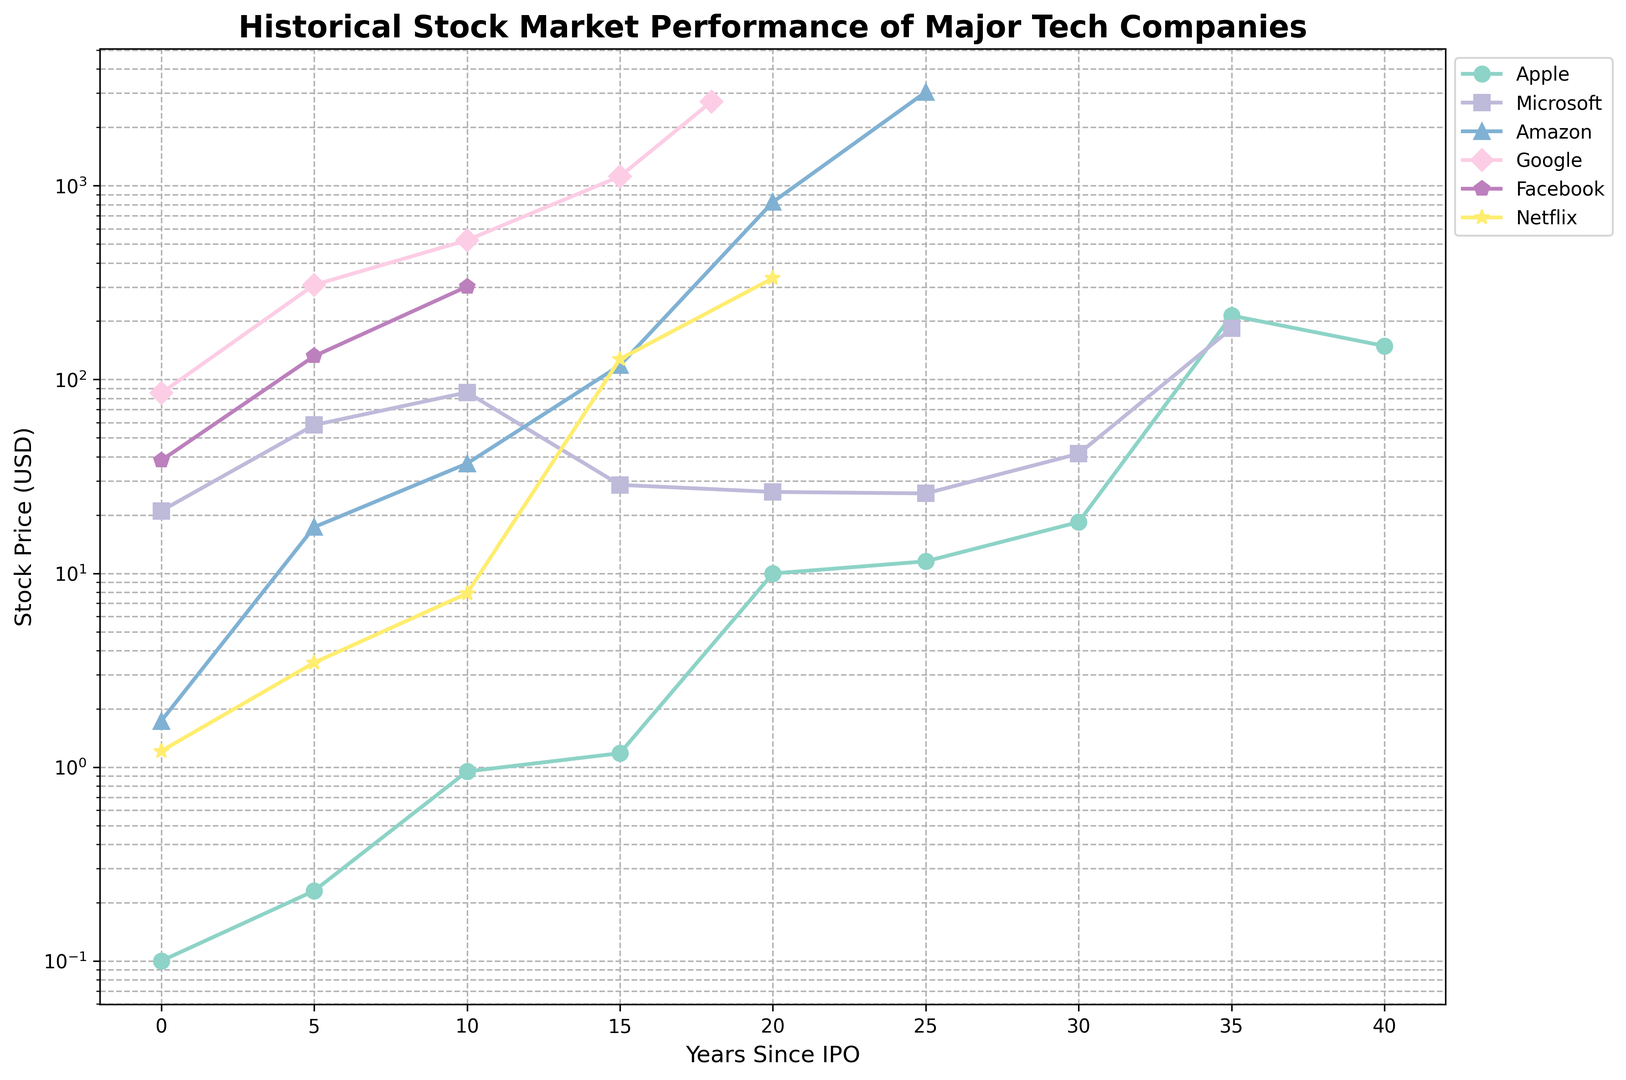Which company had the highest stock price 20 years after its IPO? To find the company with the highest stock price 20 years after IPO, check the stock prices at the 20-year mark for each company. Apple has a stock price of 9.98, Microsoft 26.30, Amazon 823.48, Google is not available at 20 years, Facebook is also not available, Netflix 333.29. Therefore, Amazon has the highest stock price at 823.48 USD.
Answer: Amazon Which company's stock price increased the most from 0 to 5 years since IPO? To determine the largest increase from 0 to 5 years, subtract the 0-year stock price from the 5-year stock price for each company: Apple (0.23 - 0.10 = 0.13), Microsoft (58.25 - 21.00 = 37.25), Amazon (17.31 - 1.73 = 15.58), Google (307.65 - 85.00 = 222.65), Facebook (131.98 - 38.23 = 93.75), and Netflix (3.46 - 1.21 = 2.25). Google had the highest increase of 222.65 USD.
Answer: Google Which company has the steepest growth curve after 15 years? Observing the slopes of the lines after 15 years, compare the steepness visually. Apple's stock sees significant growth after 15 years, reaching 213.69 at 35 years. Microsoft's and Amazon's growth are also notable but not as steep visually as Apple’s in the plotted time period from 15 to 35. Therefore, Apple has the steepest growth curve after 15 years.
Answer: Apple Which company maintained a nearly consistent stock price from 15 to 20 years since its IPO? Look at the stock price trajectories between 15 and 20 years. Apple grew from 1.18 to 9.98, Microsoft remained almost the same with 28.60 to 26.30, Amazon grew from 118.40 to 823.48, and Netflix grew significantly from 7.87 to 127.49. Microsoft’s stock price shows the least variation, indicating consistency.
Answer: Microsoft By how much did Facebook’s stock price increase from 5 years to 10 years since its IPO? Calculate the difference between the stock price at 5 years and 10 years for Facebook: 301.71 - 131.98 = 169.73. Therefore, Facebook’s stock price increased by 169.73 USD.
Answer: 169.73 Compare the stock price of Apple and Amazon at the 30-year mark; which is higher? Check the stock prices of Apple and Amazon at 30 years. Apple has a stock price of 18.39, while Amazon's stock price at 30 years is N/A, indicating data is not available. Therefore, based on available information, only Apple can be referenced.
Answer: Apple What is the average stock price of Microsoft at 0, 5, and 10 years since its IPO? Calculate the average by summing the stock prices and dividing by the number of data points: (21.00 + 58.25 + 85.81) / 3 = 165.06 / 3 = 55.02 USD.
Answer: 55.02 Which company shows the first evidence of stock price logarithmic growth? Examine the figure for companies' stock prices transforming into a steep curve typical in logarithmic growth. Visual inspection shows Amazon’s stock price growth appears logarithmic starting around the 10 to 15-year mark.
Answer: Amazon Which two companies have their highest recorded stock prices in the plotted data set? Inspect the highest points on the figure for each company: Apple (213.69), Microsoft (183.51), Amazon (3044.01), Google (2720.29), Facebook (301.71), Netflix (333.29). Therefore, Amazon and Google have the highest recorded stock prices.
Answer: Amazon, Google 